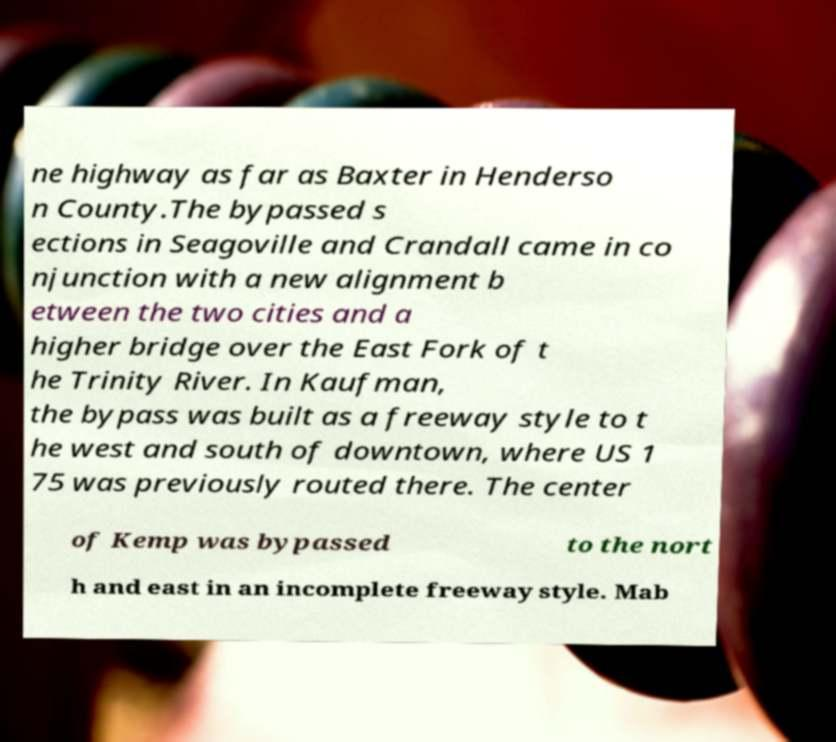What messages or text are displayed in this image? I need them in a readable, typed format. ne highway as far as Baxter in Henderso n County.The bypassed s ections in Seagoville and Crandall came in co njunction with a new alignment b etween the two cities and a higher bridge over the East Fork of t he Trinity River. In Kaufman, the bypass was built as a freeway style to t he west and south of downtown, where US 1 75 was previously routed there. The center of Kemp was bypassed to the nort h and east in an incomplete freeway style. Mab 